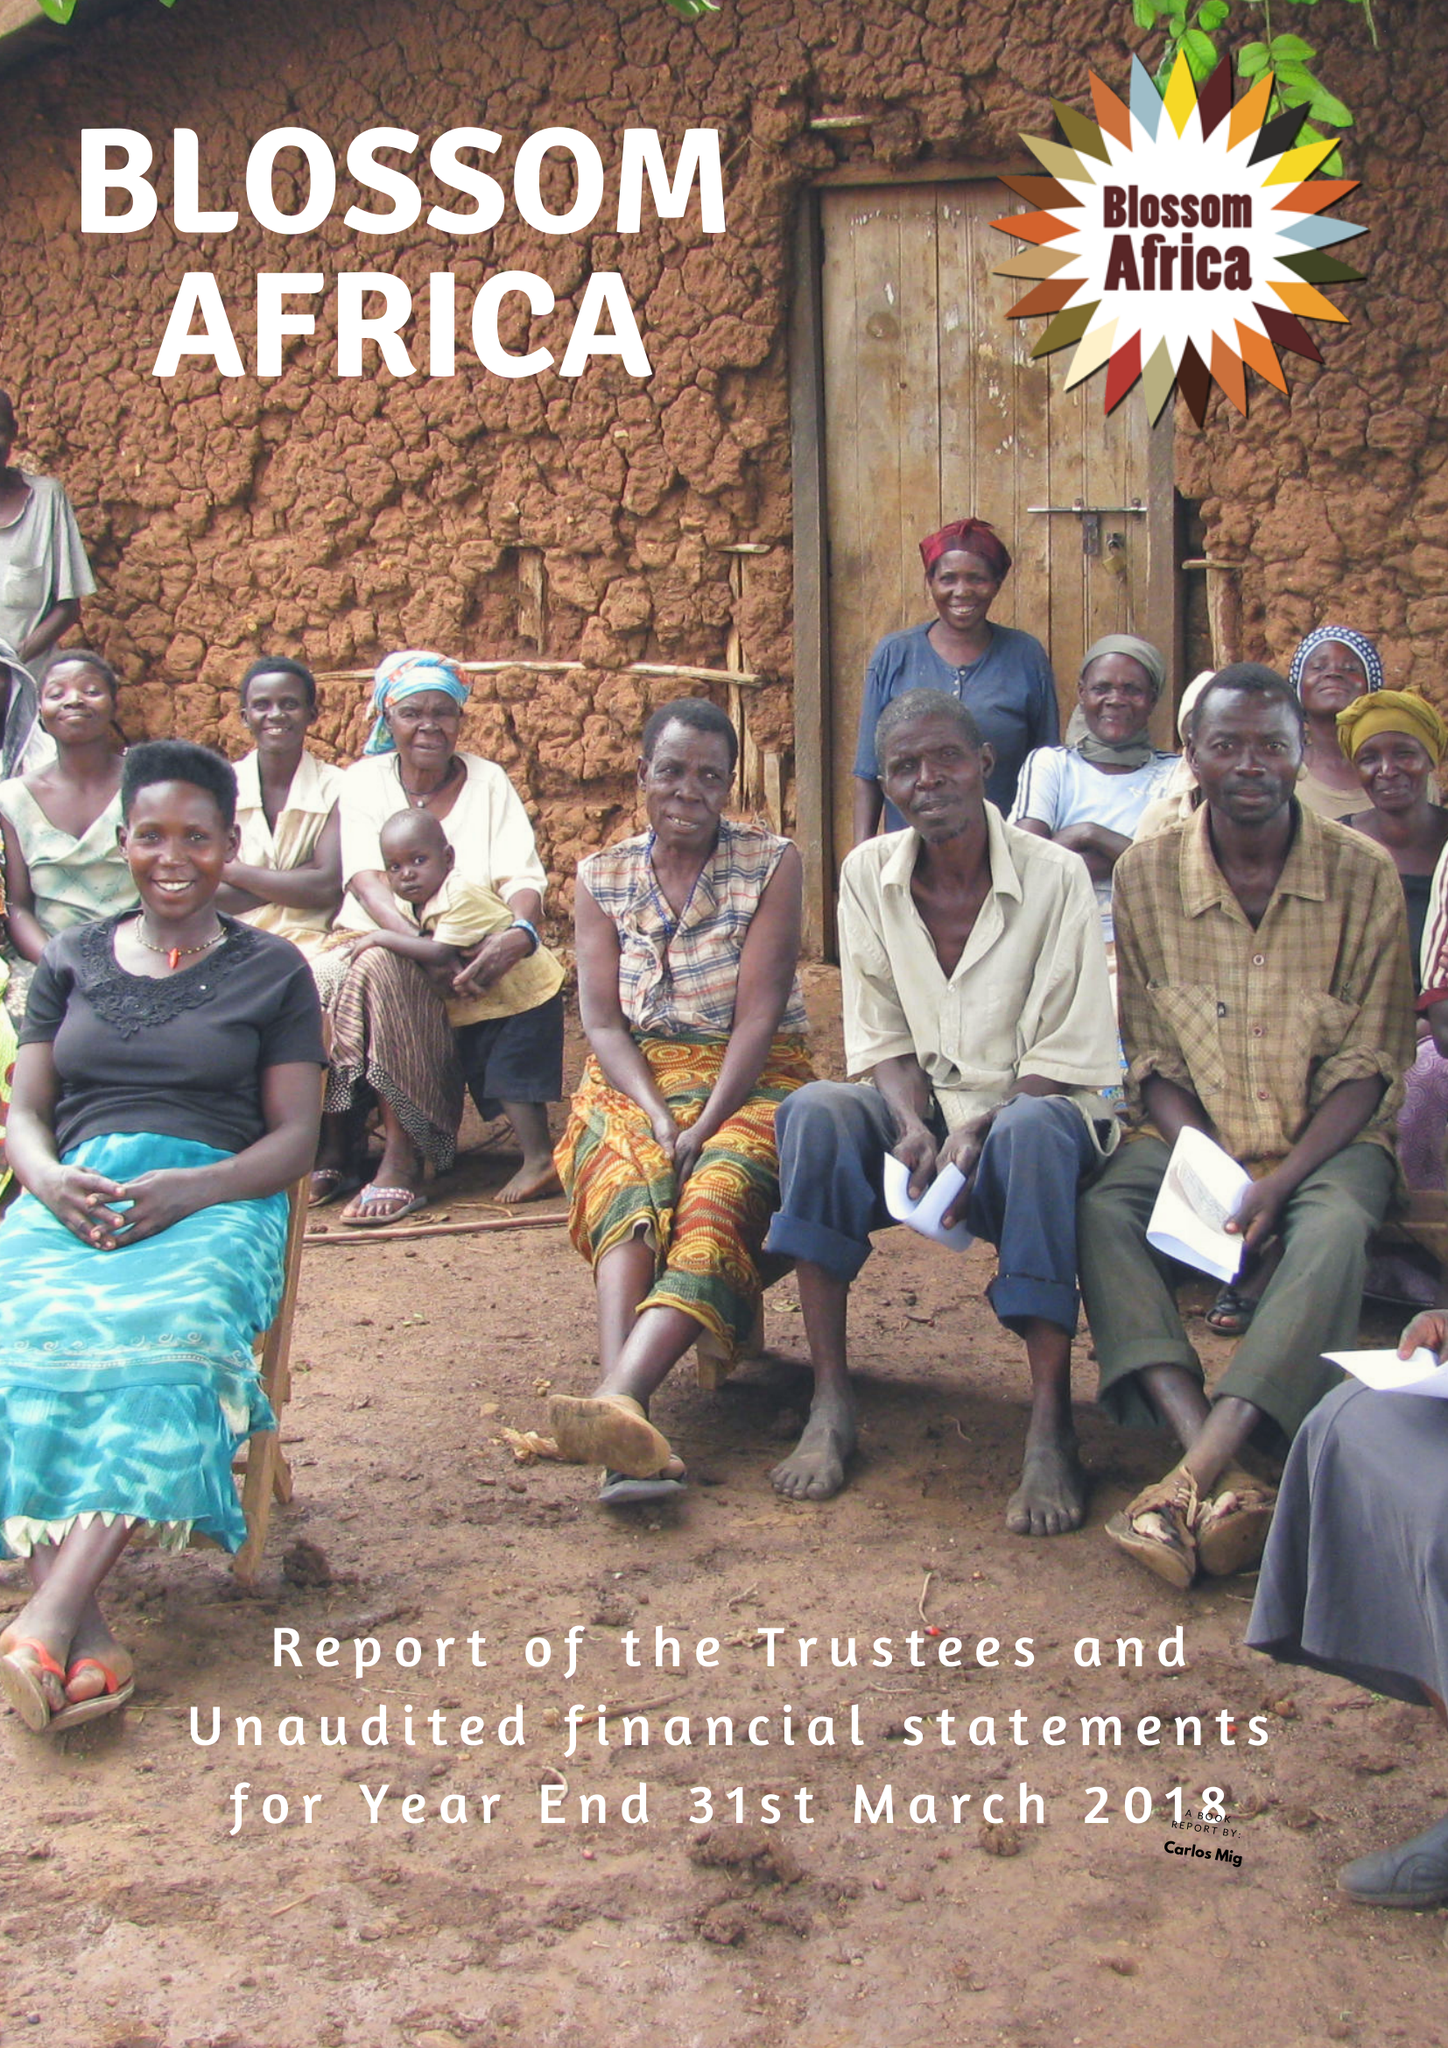What is the value for the spending_annually_in_british_pounds?
Answer the question using a single word or phrase. 839.00 